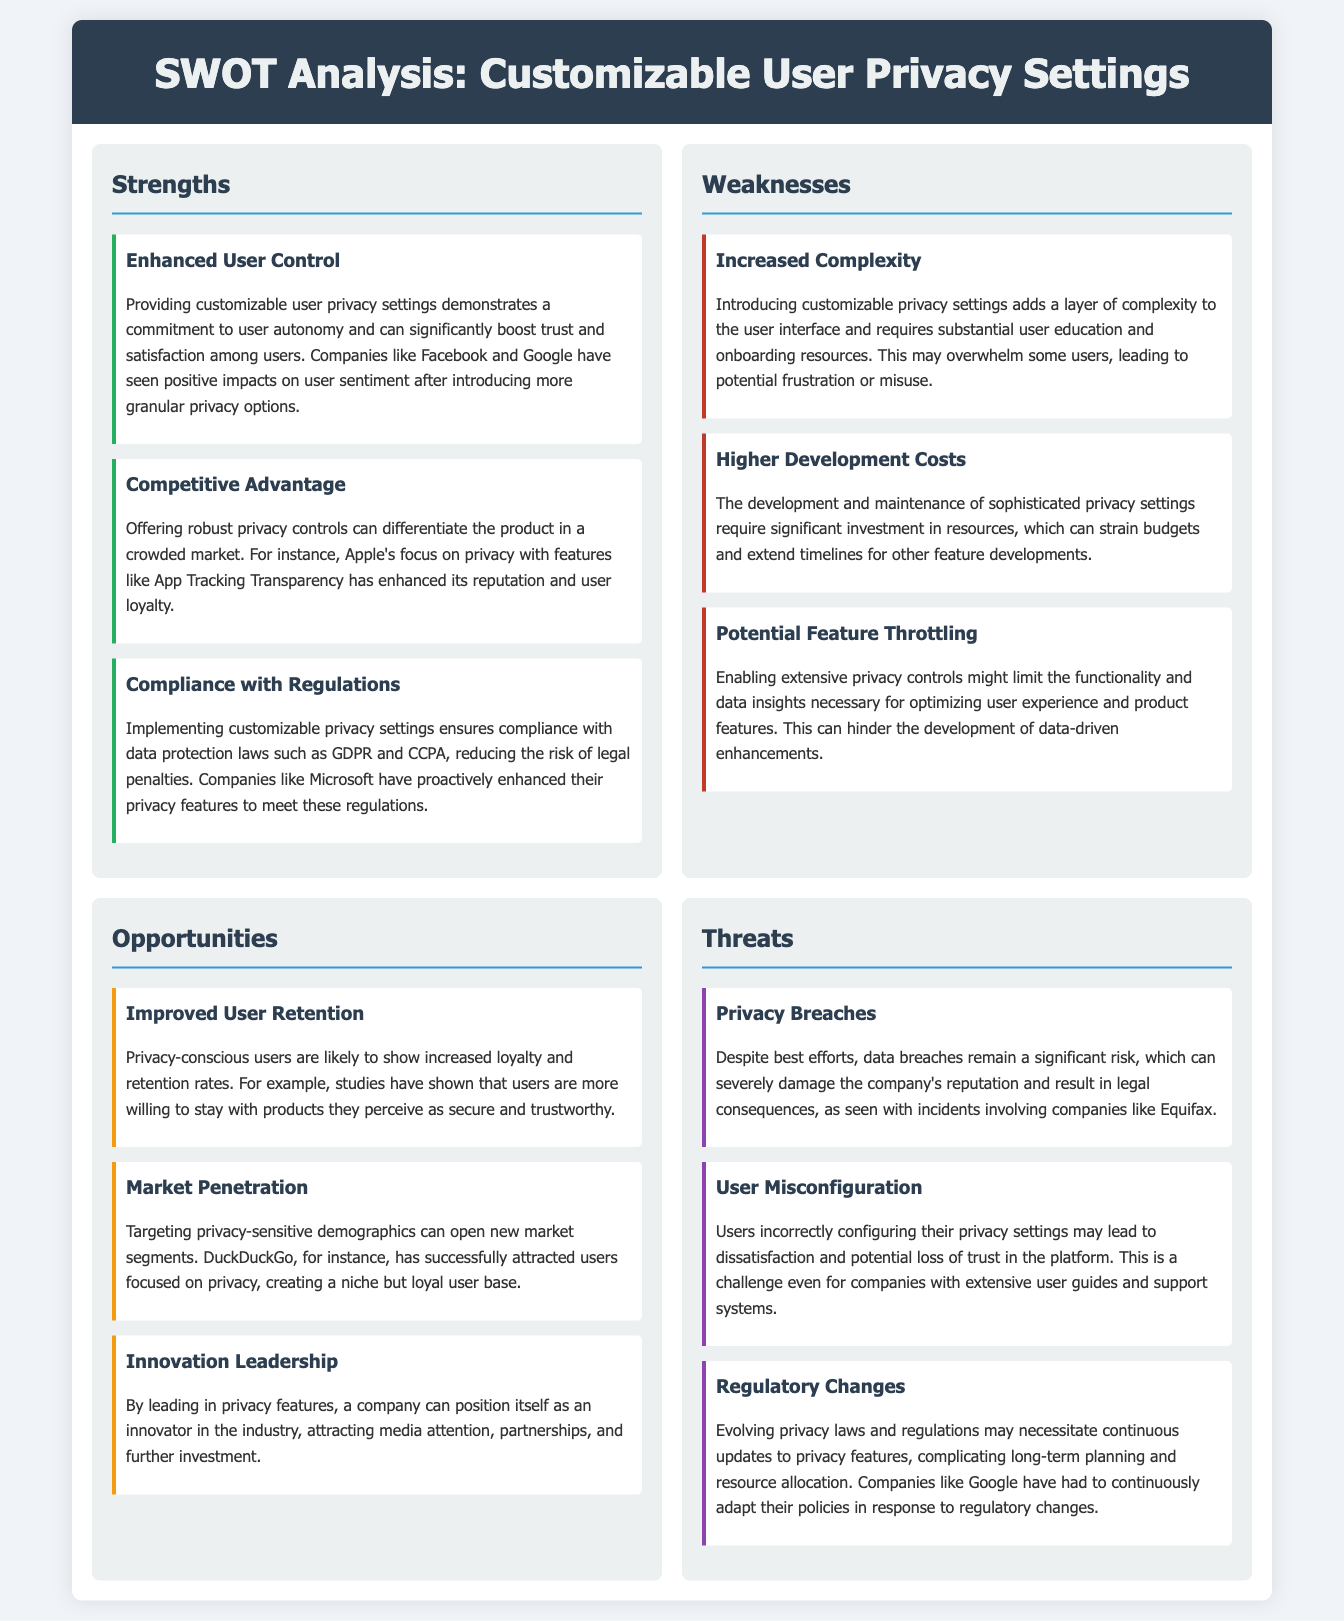What is a strength of customizable user privacy settings? A strength listed in the document is "Enhanced User Control", which suggests that such settings enhance user autonomy and trust.
Answer: Enhanced User Control What is one weakness associated with customizable user privacy settings? The document states that a weakness is "Increased Complexity," which implies that users might feel overwhelmed by the intricate settings.
Answer: Increased Complexity How many opportunities are identified in the SWOT analysis? The document lists three opportunities under the opportunities section.
Answer: Three What can improve user retention according to the analysis? The document states that "Improved User Retention" is an opportunity emphasizing loyalty among privacy-conscious users.
Answer: Improved User Retention What major threat is mentioned related to data security? The document highlights "Privacy Breaches" as a significant threat that can damage reputation and lead to legal issues.
Answer: Privacy Breaches What feature can differentiate the product in a crowded market? The document indicates that "Competitive Advantage" can be gained by offering robust privacy controls.
Answer: Competitive Advantage What is a potential outcome of user misconfiguration? According to the document, user misconfiguration may lead to "dissatisfaction" and a loss of trust in the platform.
Answer: Dissatisfaction What product is cited as successfully attracting privacy-conscious users? The document cites "DuckDuckGo" as an example of a product that has attracted users focusing on privacy.
Answer: DuckDuckGo 